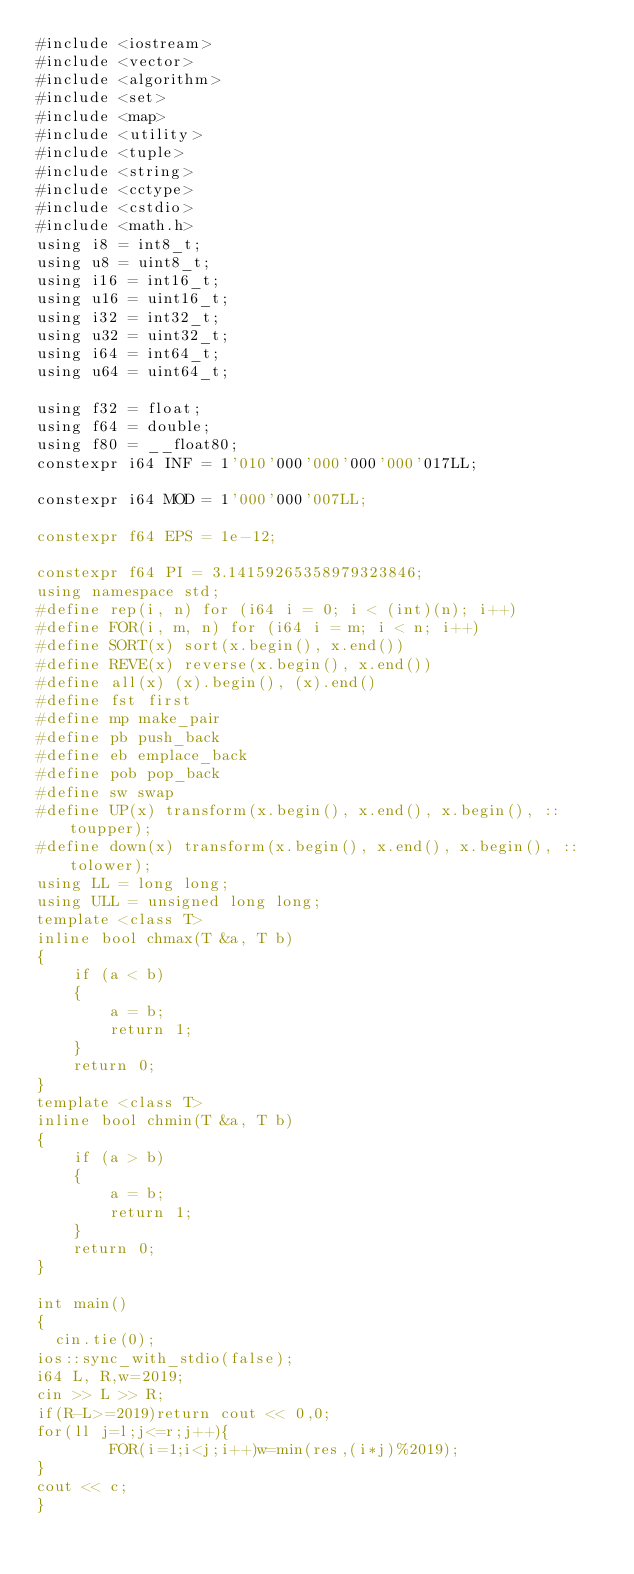<code> <loc_0><loc_0><loc_500><loc_500><_C++_>#include <iostream>
#include <vector>
#include <algorithm>
#include <set>
#include <map>
#include <utility>
#include <tuple>
#include <string>
#include <cctype>
#include <cstdio>
#include <math.h>
using i8 = int8_t;
using u8 = uint8_t;
using i16 = int16_t;
using u16 = uint16_t;
using i32 = int32_t;
using u32 = uint32_t;
using i64 = int64_t;
using u64 = uint64_t;

using f32 = float;
using f64 = double;
using f80 = __float80;
constexpr i64 INF = 1'010'000'000'000'000'017LL;

constexpr i64 MOD = 1'000'000'007LL;

constexpr f64 EPS = 1e-12;

constexpr f64 PI = 3.14159265358979323846;
using namespace std;
#define rep(i, n) for (i64 i = 0; i < (int)(n); i++)
#define FOR(i, m, n) for (i64 i = m; i < n; i++)
#define SORT(x) sort(x.begin(), x.end())
#define REVE(x) reverse(x.begin(), x.end())
#define all(x) (x).begin(), (x).end()
#define fst first
#define mp make_pair
#define pb push_back
#define eb emplace_back
#define pob pop_back
#define sw swap
#define UP(x) transform(x.begin(), x.end(), x.begin(), ::toupper);
#define down(x) transform(x.begin(), x.end(), x.begin(), ::tolower);
using LL = long long;
using ULL = unsigned long long;
template <class T>
inline bool chmax(T &a, T b)
{
    if (a < b)
    {
        a = b;
        return 1;
    }
    return 0;
}
template <class T>
inline bool chmin(T &a, T b)
{
    if (a > b)
    {
        a = b;
        return 1;
    }
    return 0;
}

int main()
{
  cin.tie(0);
ios::sync_with_stdio(false);
i64 L, R,w=2019;
cin >> L >> R;
if(R-L>=2019)return cout << 0,0;
for(ll j=l;j<=r;j++){
		FOR(i=1;i<j;i++)w=min(res,(i*j)%2019);
}
cout << c;
}</code> 